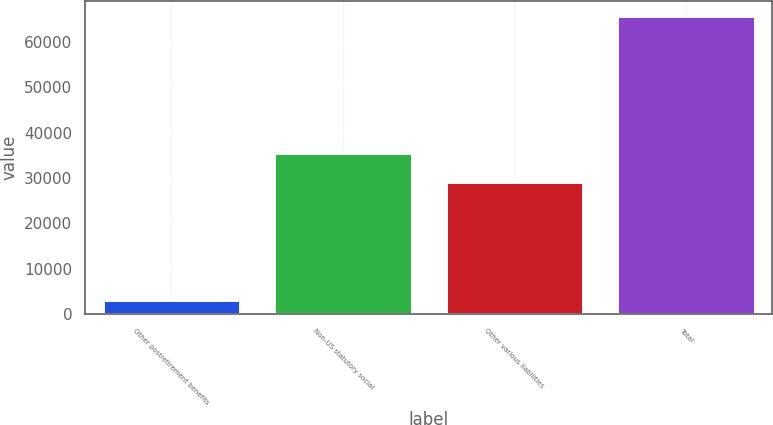Convert chart. <chart><loc_0><loc_0><loc_500><loc_500><bar_chart><fcel>Other postretirement benefits<fcel>Non-US statutory social<fcel>Other various liabilities<fcel>Total<nl><fcel>3082<fcel>35465<fcel>29205<fcel>65682<nl></chart> 